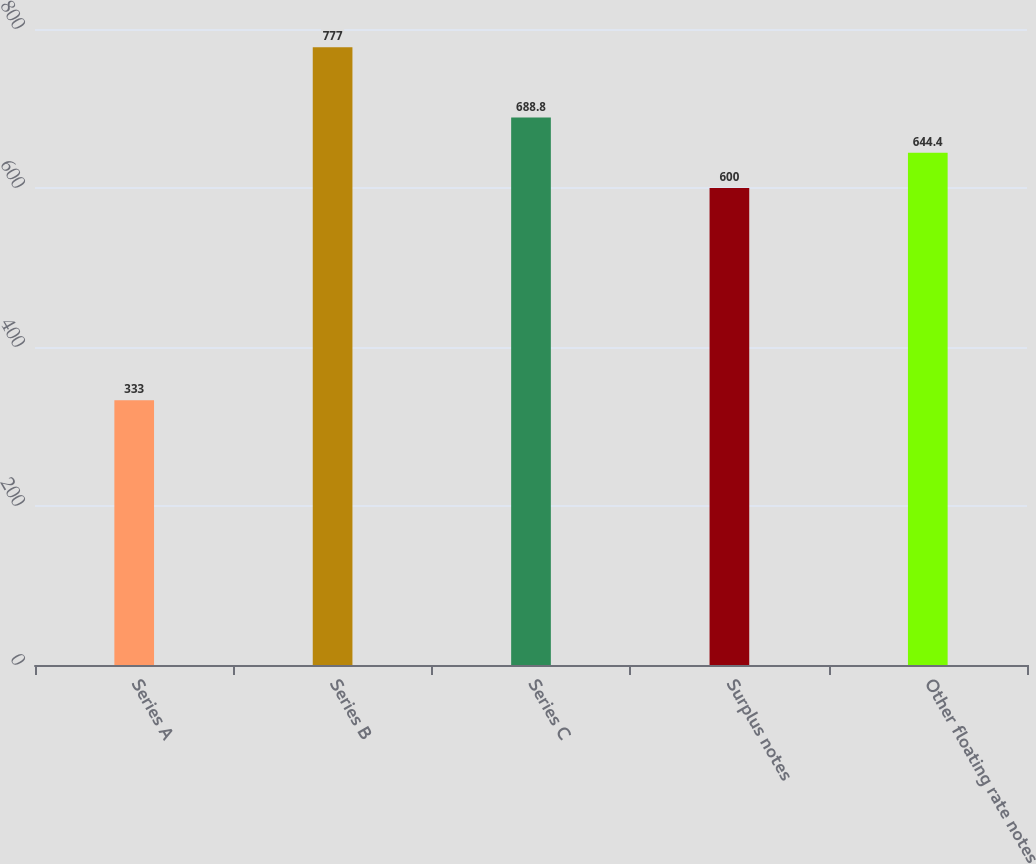<chart> <loc_0><loc_0><loc_500><loc_500><bar_chart><fcel>Series A<fcel>Series B<fcel>Series C<fcel>Surplus notes<fcel>Other floating rate notes<nl><fcel>333<fcel>777<fcel>688.8<fcel>600<fcel>644.4<nl></chart> 